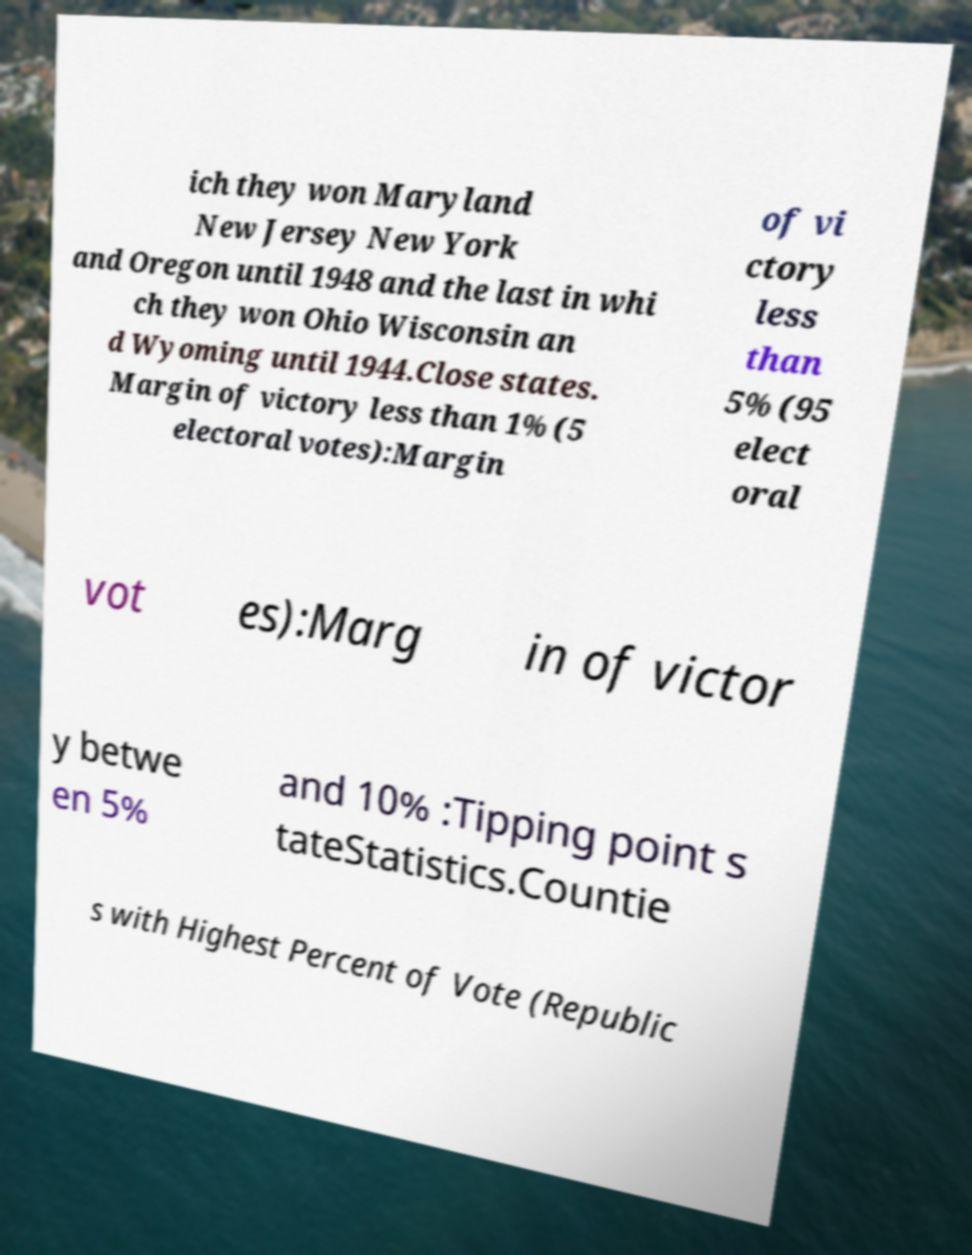I need the written content from this picture converted into text. Can you do that? ich they won Maryland New Jersey New York and Oregon until 1948 and the last in whi ch they won Ohio Wisconsin an d Wyoming until 1944.Close states. Margin of victory less than 1% (5 electoral votes):Margin of vi ctory less than 5% (95 elect oral vot es):Marg in of victor y betwe en 5% and 10% :Tipping point s tateStatistics.Countie s with Highest Percent of Vote (Republic 